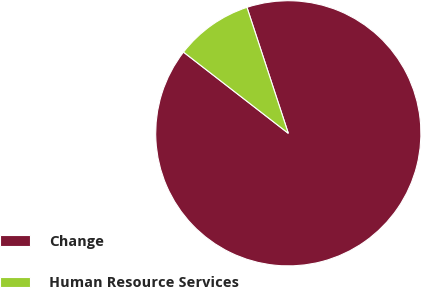Convert chart to OTSL. <chart><loc_0><loc_0><loc_500><loc_500><pie_chart><fcel>Change<fcel>Human Resource Services<nl><fcel>90.54%<fcel>9.46%<nl></chart> 